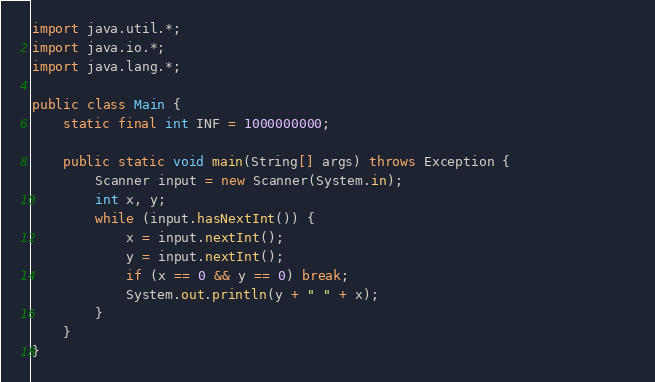<code> <loc_0><loc_0><loc_500><loc_500><_Java_>import java.util.*;
import java.io.*;
import java.lang.*;

public class Main {
    static final int INF = 1000000000;     
    
    public static void main(String[] args) throws Exception {                
        Scanner input = new Scanner(System.in);
        int x, y;
        while (input.hasNextInt()) {
            x = input.nextInt();
            y = input.nextInt();
            if (x == 0 && y == 0) break;
            System.out.println(y + " " + x);
        }
    }         
}</code> 